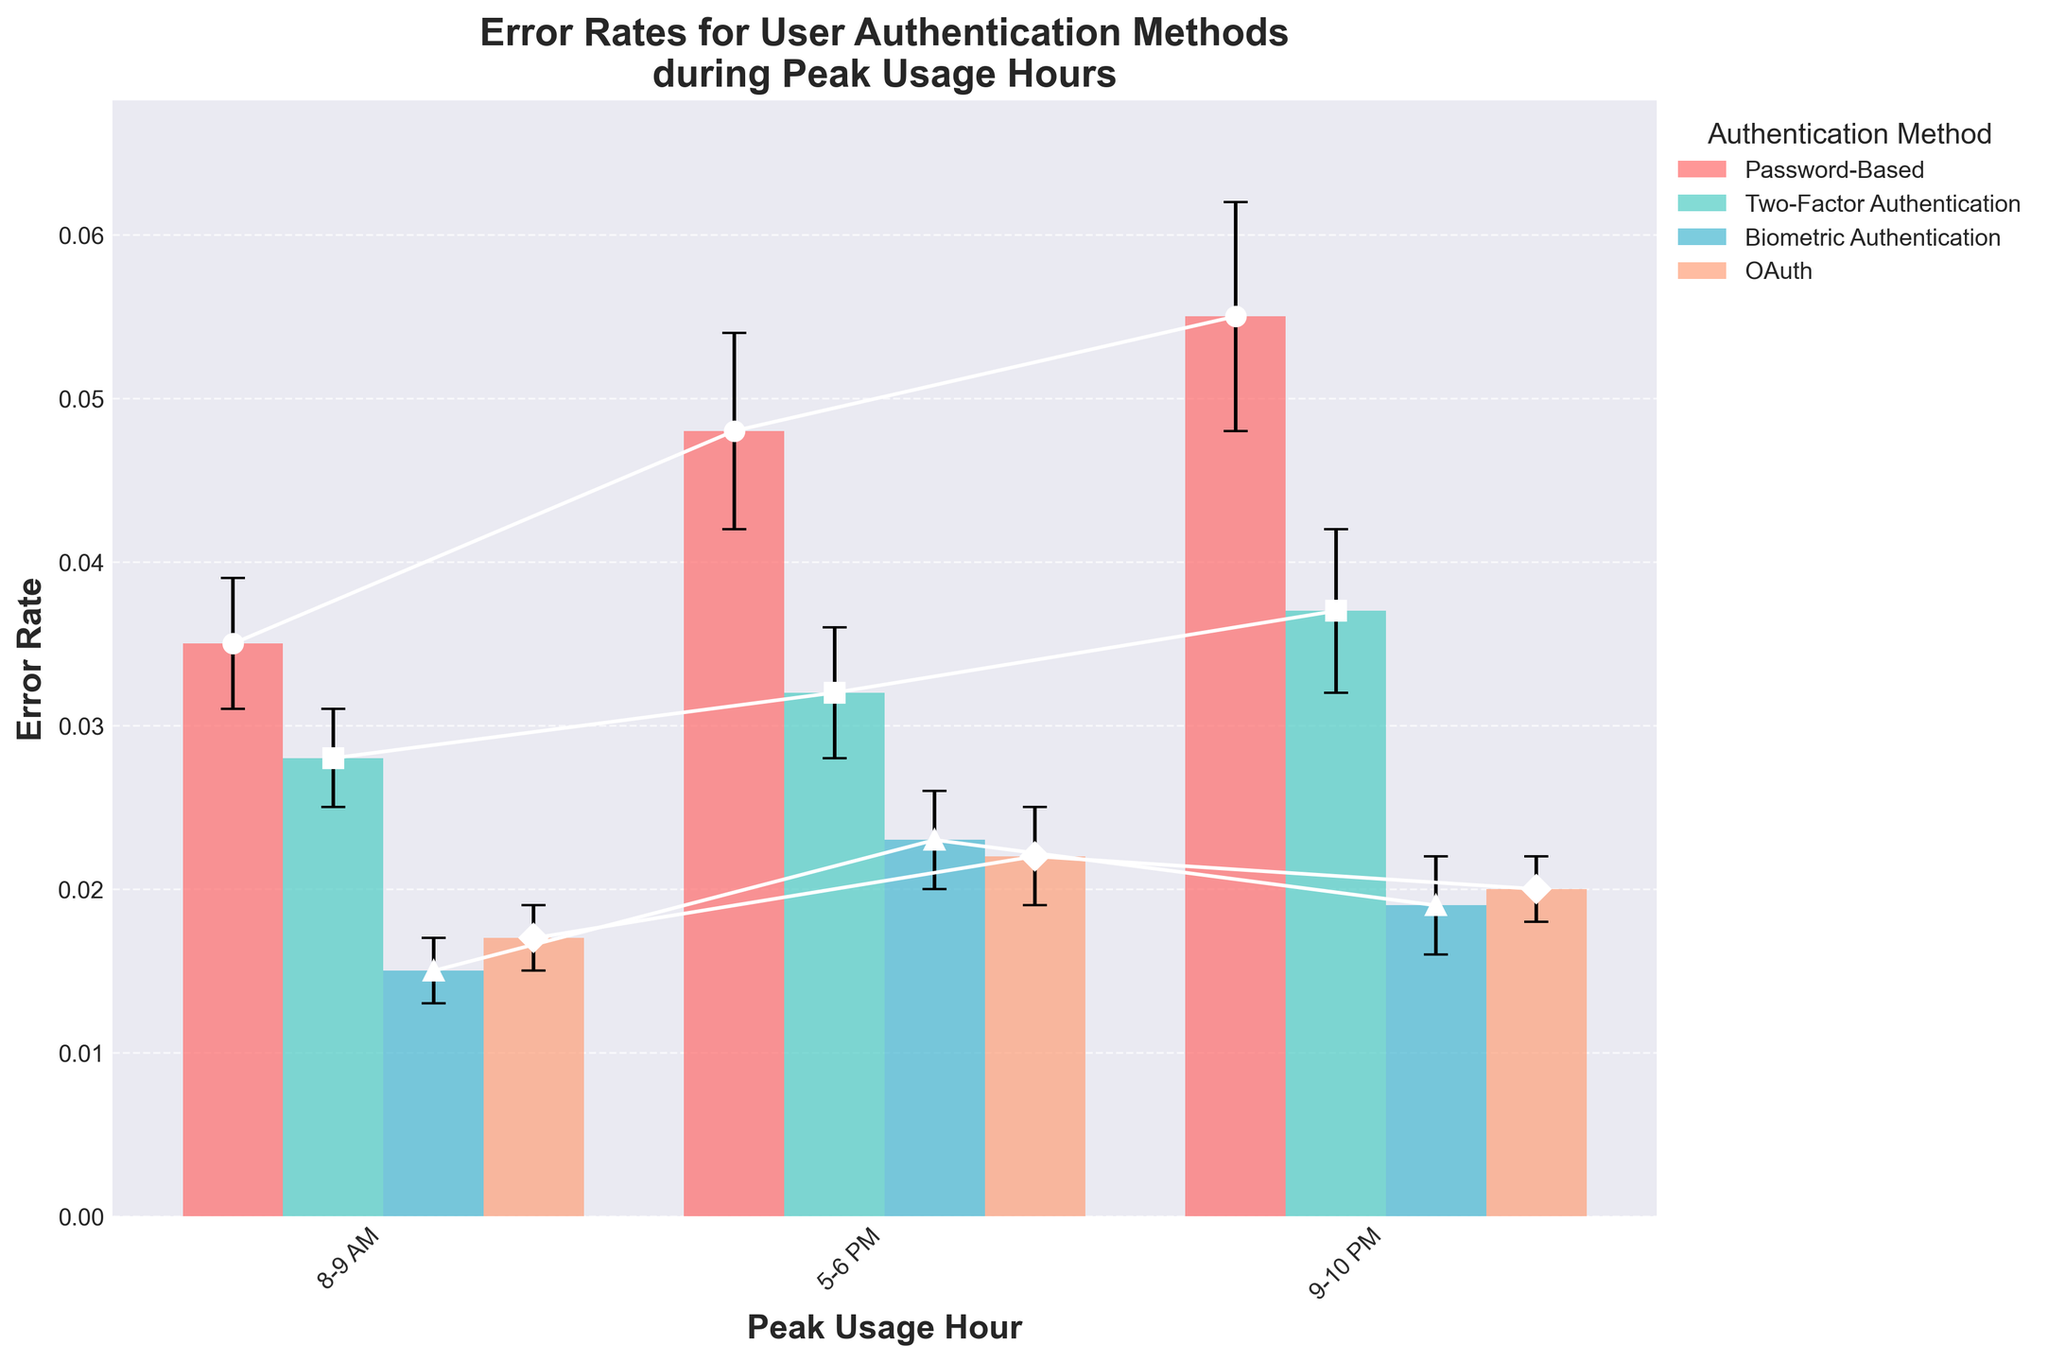What is the title of the plot? The title of the plot is typically located at the top of the figure in larger and bold font to provide an overview or main subject. In this plot, the title is "Error Rates for User Authentication Methods during Peak Usage Hours."
Answer: Error Rates for User Authentication Methods during Peak Usage Hours What are the peak usage hours shown on the x-axis? The x-axis labels typically show the categories for which the data is plotted, which here represent different time intervals: "8-9 AM," "5-6 PM," and "9-10 PM."
Answer: 8-9 AM, 5-6 PM, 9-10 PM Which authentication method has the lowest error rate overall? To find the authentication method with the lowest error rate, look across all bars for each method and identify the minimum value. The Biometric Authentication method consistently exhibits the lowest error rates.
Answer: Biometric Authentication At what time does Password-Based authentication have the highest error rate? For Password-Based authentication, identify the tallest bar(s) in its series at each time interval. The highest error rate for Password-Based authentication appears during the "9-10 PM" time slot.
Answer: 9-10 PM How much higher is the error rate for Password-Based authentication at 9-10 PM compared to 8-9 AM? Identify the error rates for Password-Based authentication at "9-10 PM" (0.055) and "8-9 AM" (0.035). Subtract the earlier rate from the later rate to find the difference: 0.055 - 0.035 = 0.020.
Answer: 0.020 Which user authentication method shows the smallest error rate variation during peak hours? The standard deviations (error bars) indicate the variation. Biometric Authentication has smaller error bars across the three time intervals, indicating less variation.
Answer: Biometric Authentication How do the error rates of Two-Factor Authentication and OAuth compare at 8-9 AM? Identify the heights of the bars for each authentication method at "8-9 AM." Two-Factor Authentication has an error rate of 0.028, which is higher than OAuth's error rate of 0.017.
Answer: Two-Factor Authentication has a higher error rate than OAuth at 8-9 AM Which authentication method shows the most significant increase in error rate from 8-9 AM to 5-6 PM? Calculate the difference in error rates between 8-9 AM and 5-6 PM for each method. Password-Based authentication shows the most significant increase from 0.035 to 0.048, an increase of 0.013.
Answer: Password-Based authentication What is the error rate and standard deviation for OAuth at 5-6 PM? Refer to the bar representing OAuth at "5-6 PM," where the error rate is 0.022 and the corresponding error bar (standard deviation) is 0.003.
Answer: Error rate: 0.022, Standard deviation: 0.003 